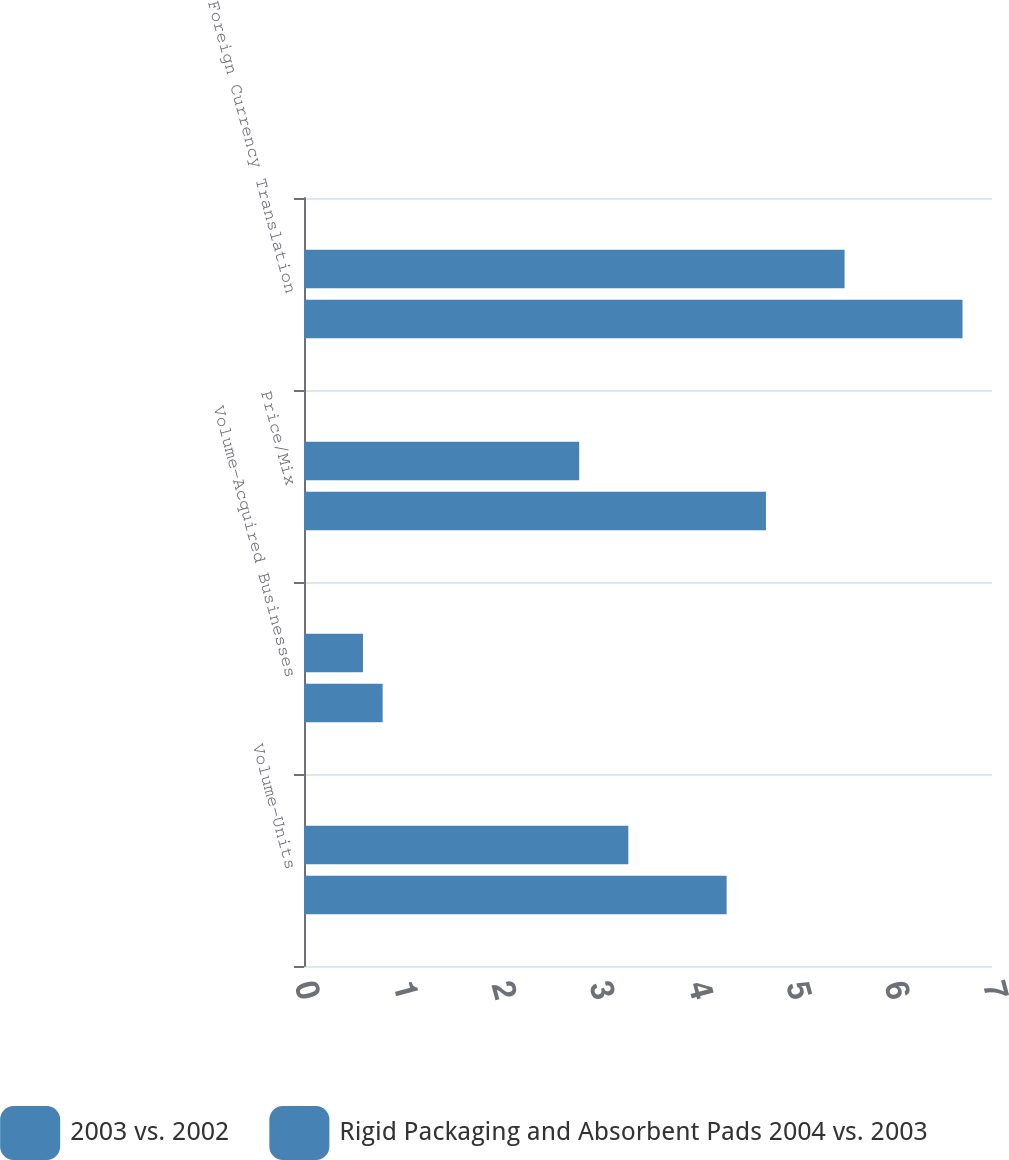Convert chart to OTSL. <chart><loc_0><loc_0><loc_500><loc_500><stacked_bar_chart><ecel><fcel>Volume-Units<fcel>Volume-Acquired Businesses<fcel>Price/Mix<fcel>Foreign Currency Translation<nl><fcel>2003 vs. 2002<fcel>3.3<fcel>0.6<fcel>2.8<fcel>5.5<nl><fcel>Rigid Packaging and Absorbent Pads 2004 vs. 2003<fcel>4.3<fcel>0.8<fcel>4.7<fcel>6.7<nl></chart> 